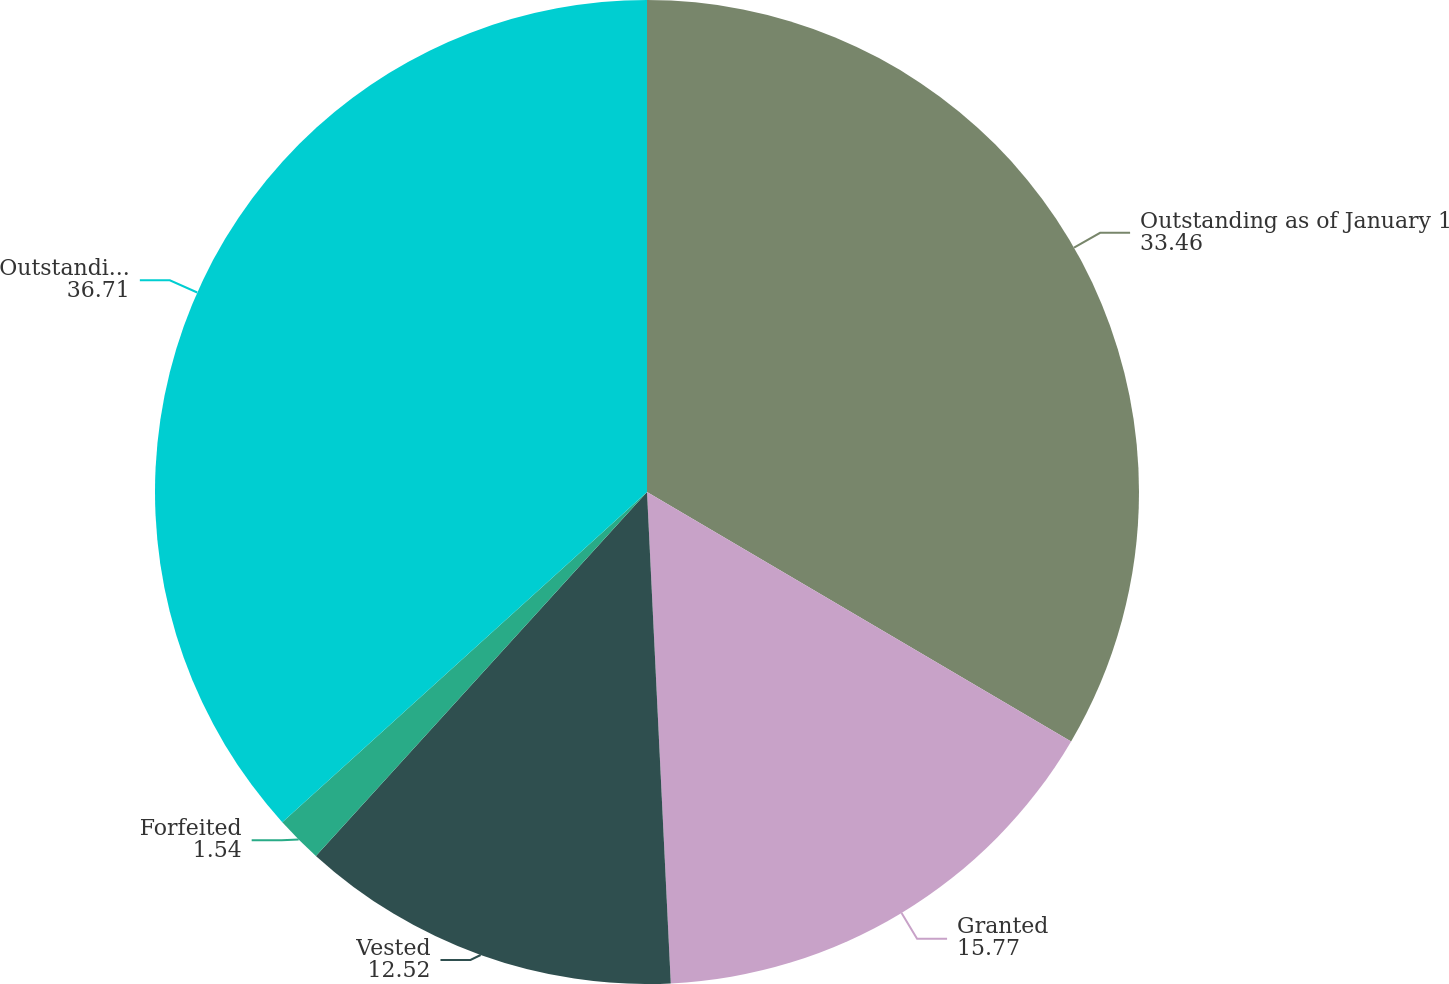Convert chart. <chart><loc_0><loc_0><loc_500><loc_500><pie_chart><fcel>Outstanding as of January 1<fcel>Granted<fcel>Vested<fcel>Forfeited<fcel>Outstanding as of December 31<nl><fcel>33.46%<fcel>15.77%<fcel>12.52%<fcel>1.54%<fcel>36.71%<nl></chart> 